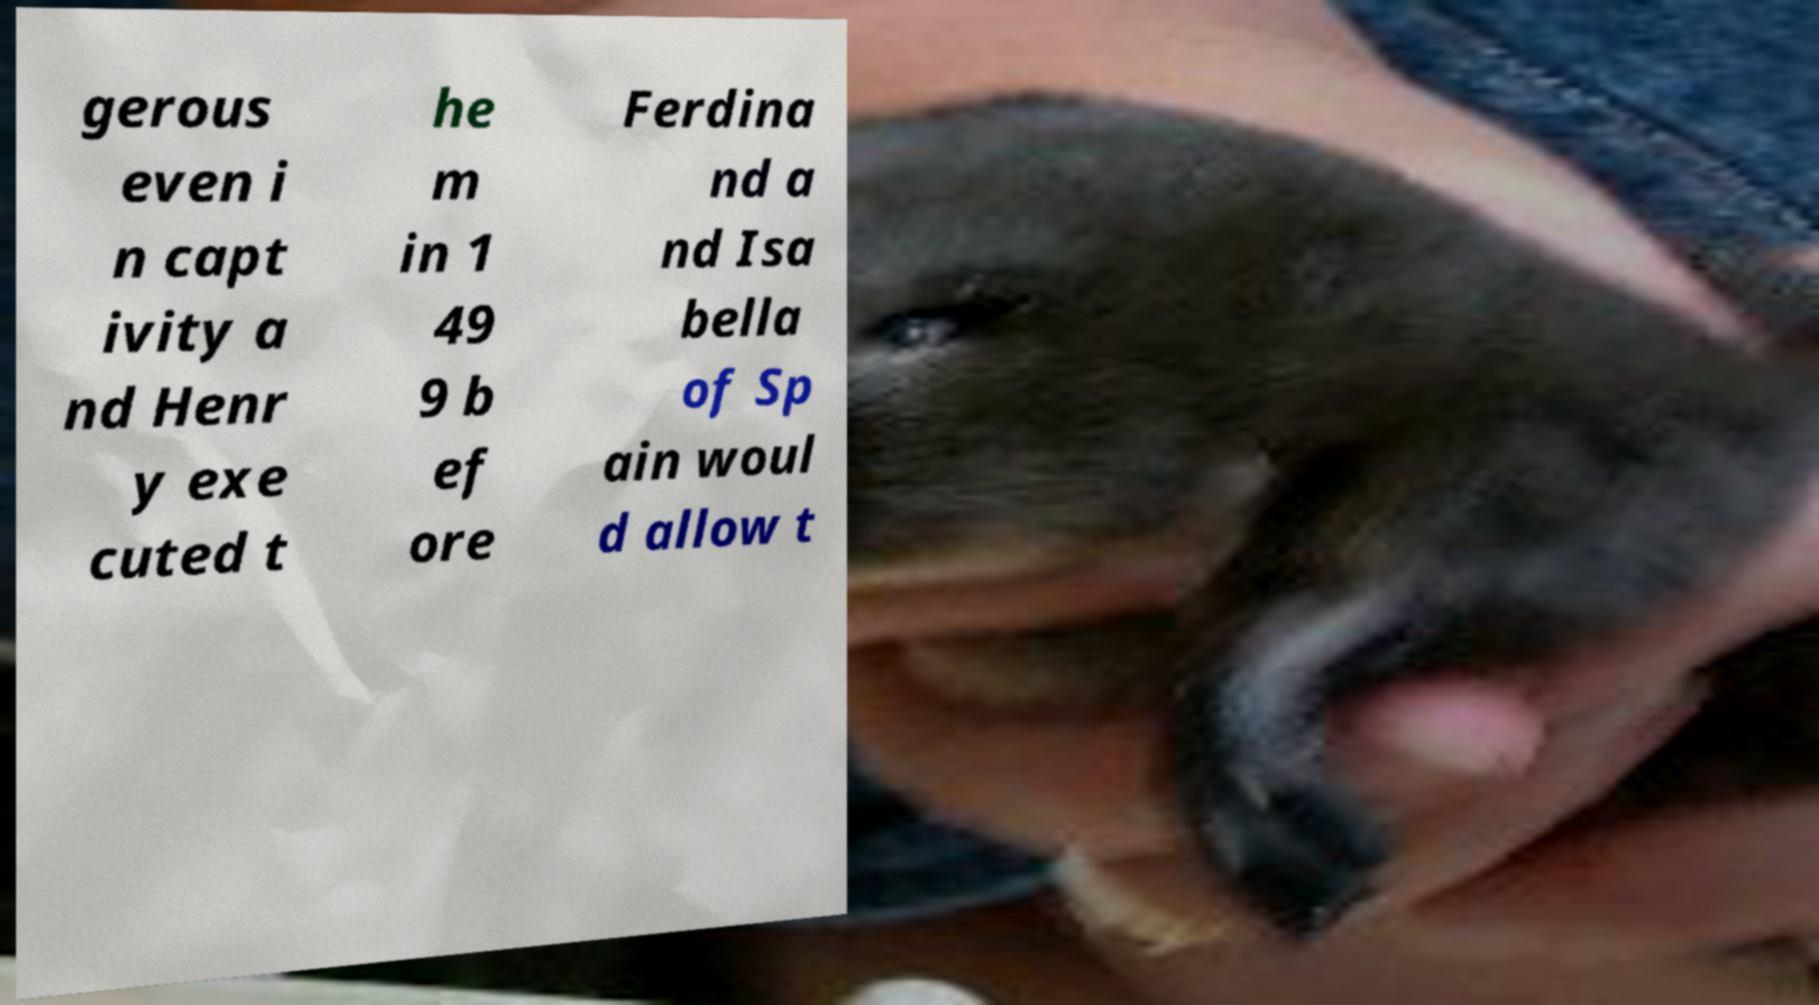For documentation purposes, I need the text within this image transcribed. Could you provide that? gerous even i n capt ivity a nd Henr y exe cuted t he m in 1 49 9 b ef ore Ferdina nd a nd Isa bella of Sp ain woul d allow t 